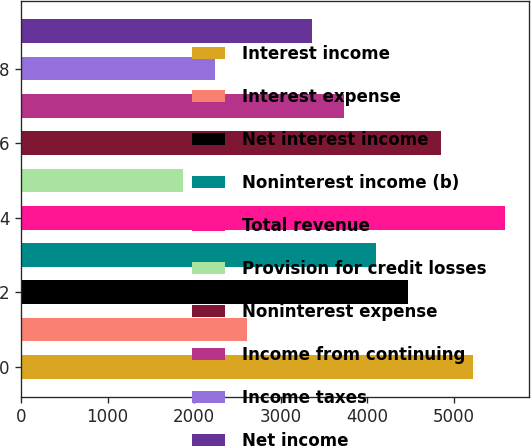Convert chart. <chart><loc_0><loc_0><loc_500><loc_500><bar_chart><fcel>Interest income<fcel>Interest expense<fcel>Net interest income<fcel>Noninterest income (b)<fcel>Total revenue<fcel>Provision for credit losses<fcel>Noninterest expense<fcel>Income from continuing<fcel>Income taxes<fcel>Net income<nl><fcel>5224.28<fcel>2612.86<fcel>4478.16<fcel>4105.1<fcel>5597.34<fcel>1866.74<fcel>4851.22<fcel>3732.04<fcel>2239.8<fcel>3358.98<nl></chart> 